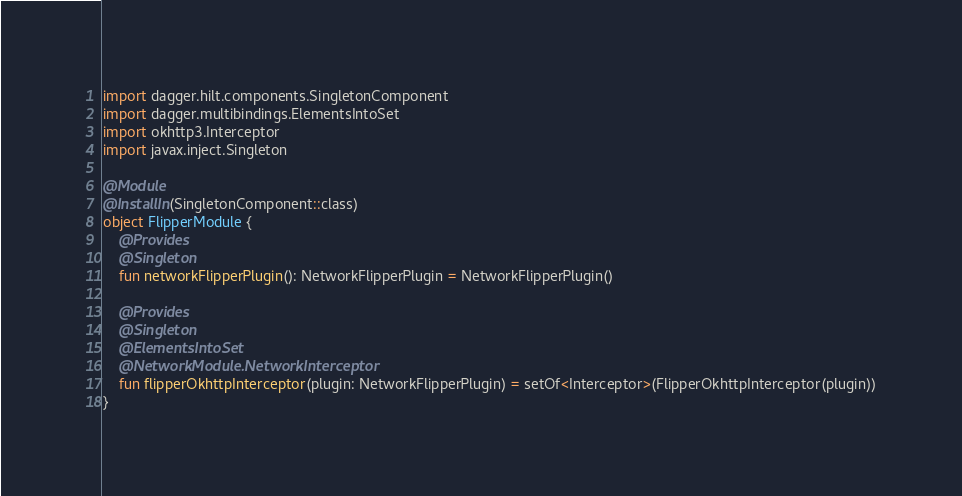<code> <loc_0><loc_0><loc_500><loc_500><_Kotlin_>import dagger.hilt.components.SingletonComponent
import dagger.multibindings.ElementsIntoSet
import okhttp3.Interceptor
import javax.inject.Singleton

@Module
@InstallIn(SingletonComponent::class)
object FlipperModule {
    @Provides
    @Singleton
    fun networkFlipperPlugin(): NetworkFlipperPlugin = NetworkFlipperPlugin()

    @Provides
    @Singleton
    @ElementsIntoSet
    @NetworkModule.NetworkInterceptor
    fun flipperOkhttpInterceptor(plugin: NetworkFlipperPlugin) = setOf<Interceptor>(FlipperOkhttpInterceptor(plugin))
}</code> 